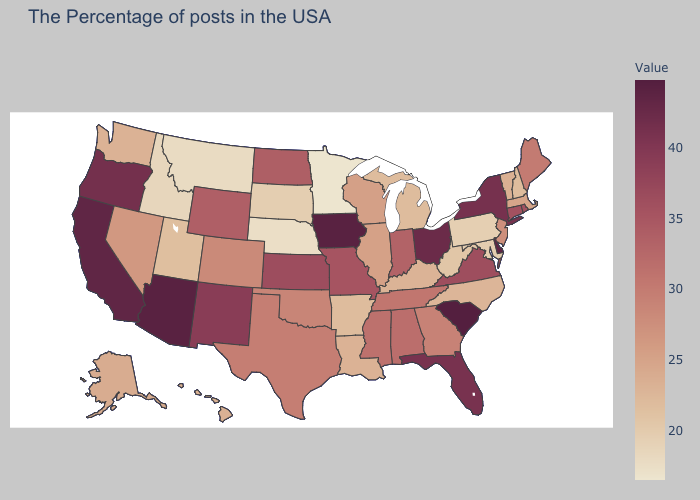Does Montana have the highest value in the USA?
Give a very brief answer. No. Which states hav the highest value in the MidWest?
Answer briefly. Iowa. Among the states that border Connecticut , does Massachusetts have the lowest value?
Concise answer only. Yes. Does Tennessee have the lowest value in the South?
Give a very brief answer. No. Does New York have the highest value in the Northeast?
Write a very short answer. Yes. Among the states that border California , does Oregon have the highest value?
Quick response, please. No. 